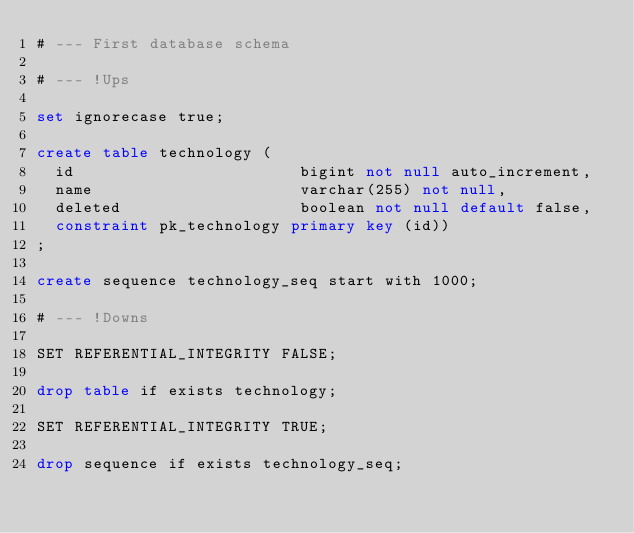<code> <loc_0><loc_0><loc_500><loc_500><_SQL_># --- First database schema

# --- !Ups

set ignorecase true;

create table technology (
  id                        bigint not null auto_increment,
  name                      varchar(255) not null,
  deleted                   boolean not null default false,
  constraint pk_technology primary key (id))
;

create sequence technology_seq start with 1000;

# --- !Downs

SET REFERENTIAL_INTEGRITY FALSE;

drop table if exists technology;

SET REFERENTIAL_INTEGRITY TRUE;

drop sequence if exists technology_seq;


</code> 